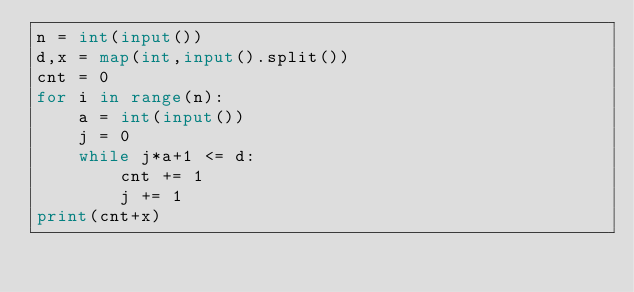<code> <loc_0><loc_0><loc_500><loc_500><_Python_>n = int(input())
d,x = map(int,input().split())
cnt = 0
for i in range(n):
    a = int(input())
    j = 0
    while j*a+1 <= d:
        cnt += 1
        j += 1
print(cnt+x)</code> 